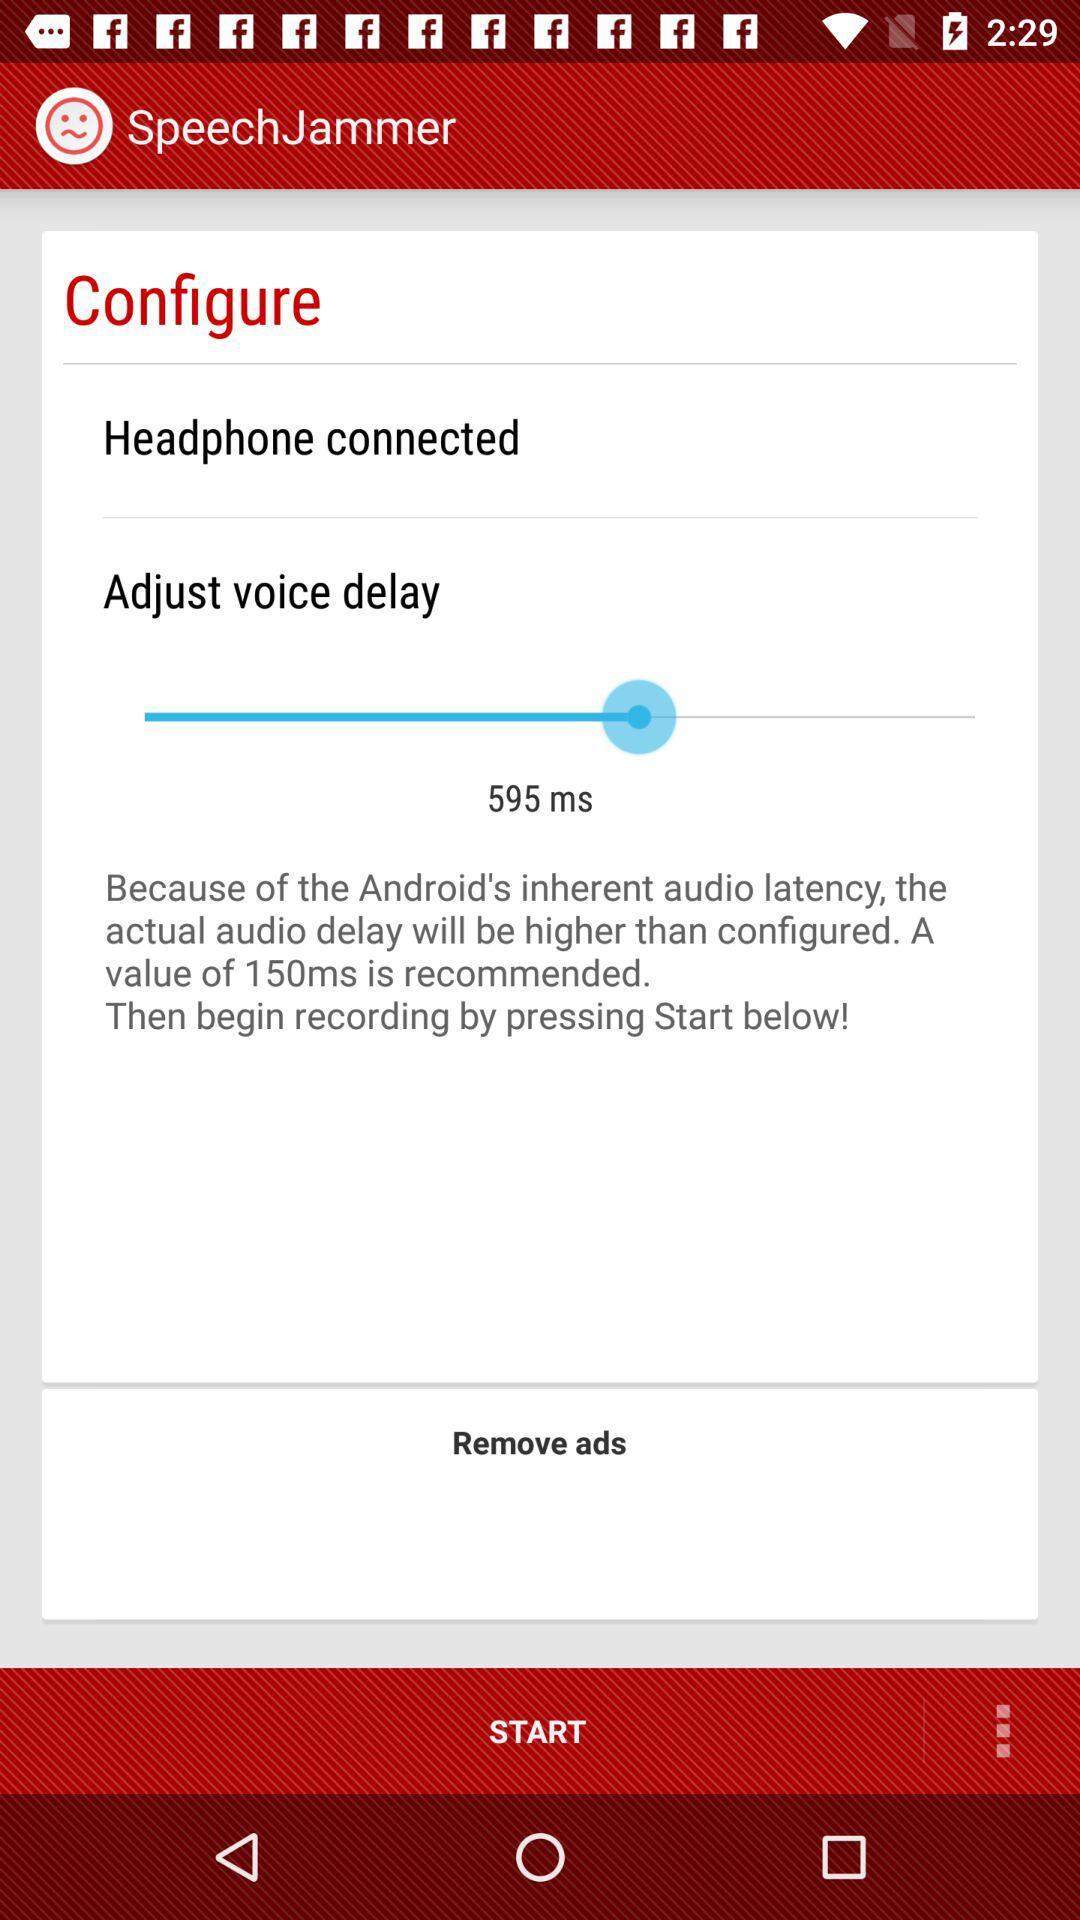What is the status of Adjust voice delay?
When the provided information is insufficient, respond with <no answer>. <no answer> 